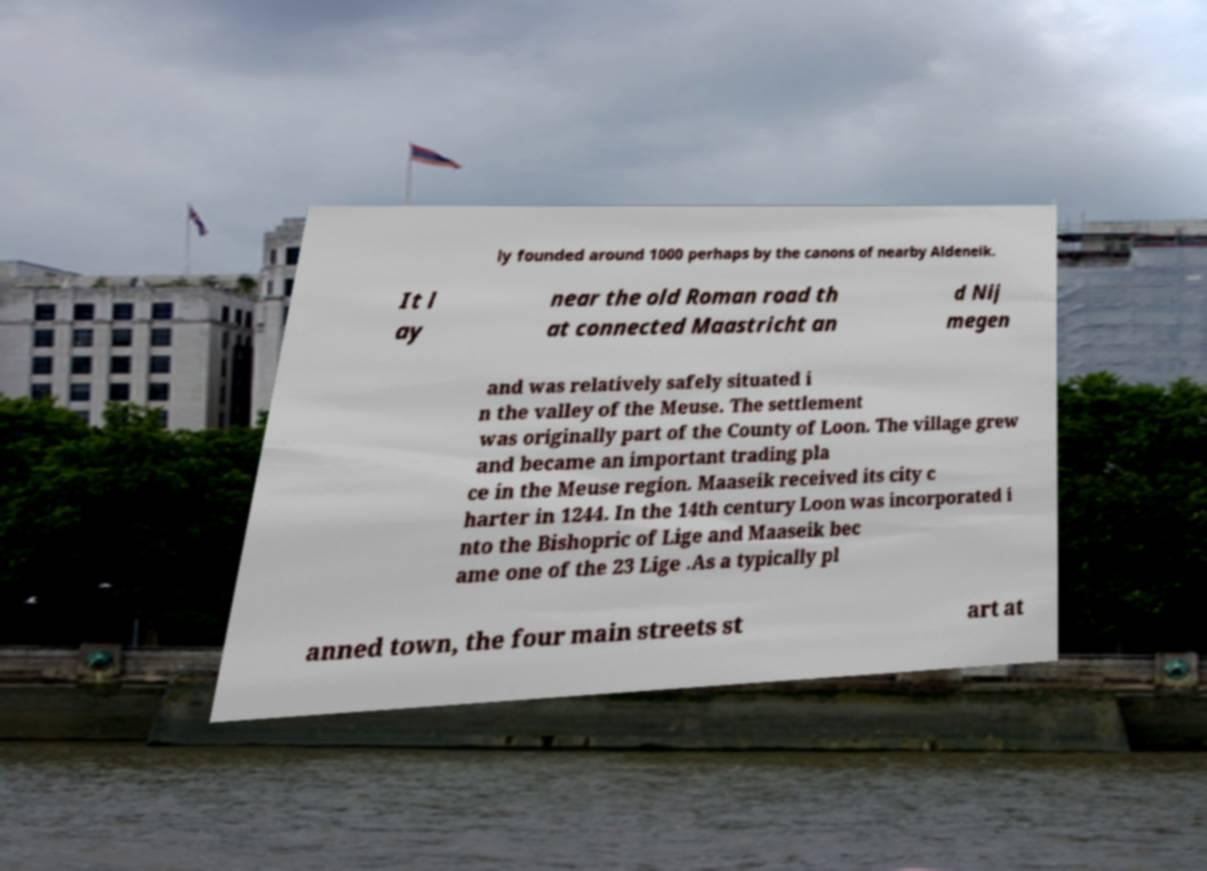Please read and relay the text visible in this image. What does it say? ly founded around 1000 perhaps by the canons of nearby Aldeneik. It l ay near the old Roman road th at connected Maastricht an d Nij megen and was relatively safely situated i n the valley of the Meuse. The settlement was originally part of the County of Loon. The village grew and became an important trading pla ce in the Meuse region. Maaseik received its city c harter in 1244. In the 14th century Loon was incorporated i nto the Bishopric of Lige and Maaseik bec ame one of the 23 Lige .As a typically pl anned town, the four main streets st art at 